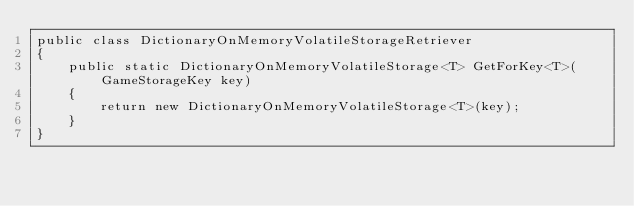<code> <loc_0><loc_0><loc_500><loc_500><_C#_>public class DictionaryOnMemoryVolatileStorageRetriever
{
	public static DictionaryOnMemoryVolatileStorage<T> GetForKey<T>(GameStorageKey key)
	{
		return new DictionaryOnMemoryVolatileStorage<T>(key);
	}
}
</code> 